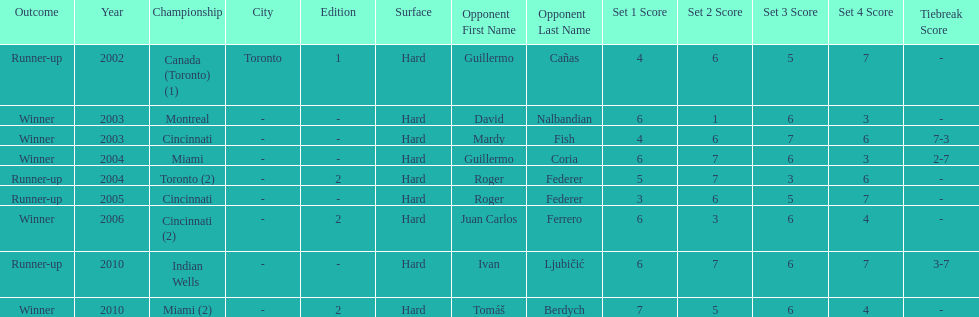Can you parse all the data within this table? {'header': ['Outcome', 'Year', 'Championship', 'City', 'Edition', 'Surface', 'Opponent First Name', 'Opponent Last Name', 'Set 1 Score', 'Set 2 Score', 'Set 3 Score', 'Set 4 Score', 'Tiebreak Score'], 'rows': [['Runner-up', '2002', 'Canada (Toronto) (1)', 'Toronto', '1', 'Hard', 'Guillermo', 'Cañas', '4', '6', '5', '7', '-'], ['Winner', '2003', 'Montreal', '-', '-', 'Hard', 'David', 'Nalbandian', '6', '1', '6', '3', '-'], ['Winner', '2003', 'Cincinnati', '-', '-', 'Hard', 'Mardy', 'Fish', '4', '6', '7', '6', '7-3'], ['Winner', '2004', 'Miami', '-', '-', 'Hard', 'Guillermo', 'Coria', '6', '7', '6', '3', '2-7'], ['Runner-up', '2004', 'Toronto (2)', '-', '2', 'Hard', 'Roger', 'Federer', '5', '7', '3', '6', '-'], ['Runner-up', '2005', 'Cincinnati', '-', '-', 'Hard', 'Roger', 'Federer', '3', '6', '5', '7', '-'], ['Winner', '2006', 'Cincinnati (2)', '-', '2', 'Hard', 'Juan Carlos', 'Ferrero', '6', '3', '6', '4', '-'], ['Runner-up', '2010', 'Indian Wells', '-', '-', 'Hard', 'Ivan', 'Ljubičić', '6', '7', '6', '7', '3-7'], ['Winner', '2010', 'Miami (2)', '-', '2', 'Hard', 'Tomáš', 'Berdych', '7', '5', '6', '4', '-']]} Was roddick a runner-up or winner more? Winner. 